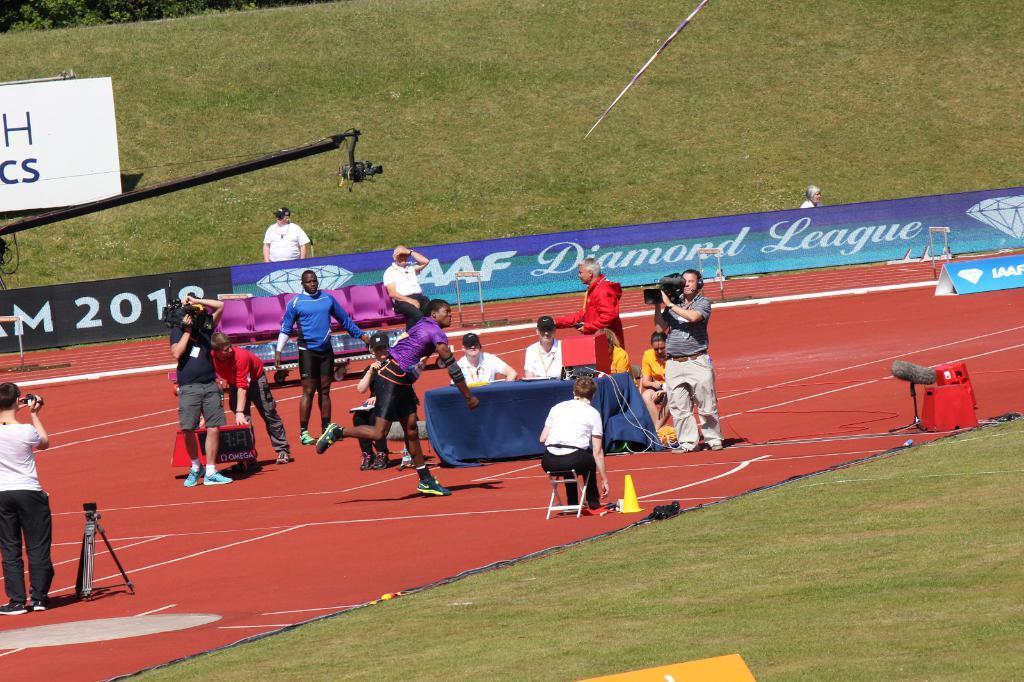How would you summarize this image in a sentence or two? In the foreground I can see a crowd on the ground, camera stand, chairs and a table. In the background I can see a fence, grass. This image is taken during a day on the ground. 